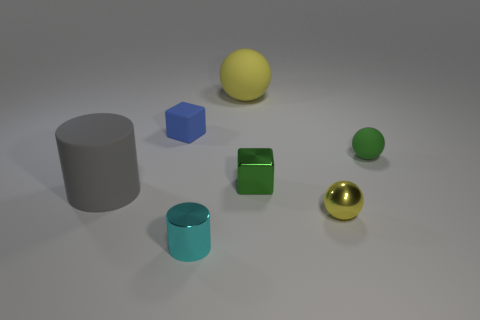Is the material of the block on the left side of the green metallic object the same as the cylinder that is behind the tiny metallic cylinder?
Provide a succinct answer. Yes. How many cyan cylinders are the same size as the blue rubber cube?
Give a very brief answer. 1. Are there fewer tiny yellow metal balls than blue metallic cylinders?
Offer a very short reply. No. There is a large matte thing that is in front of the yellow ball that is to the left of the small yellow shiny ball; what shape is it?
Make the answer very short. Cylinder. The yellow metal object that is the same size as the green shiny cube is what shape?
Your response must be concise. Sphere. Are there any blue objects that have the same shape as the green rubber object?
Your answer should be very brief. No. What material is the large gray thing?
Your answer should be compact. Rubber. There is a blue matte block; are there any tiny blue objects behind it?
Ensure brevity in your answer.  No. There is a green object that is right of the green shiny block; what number of tiny cubes are in front of it?
Your answer should be compact. 1. What material is the yellow thing that is the same size as the cyan metallic object?
Offer a very short reply. Metal. 